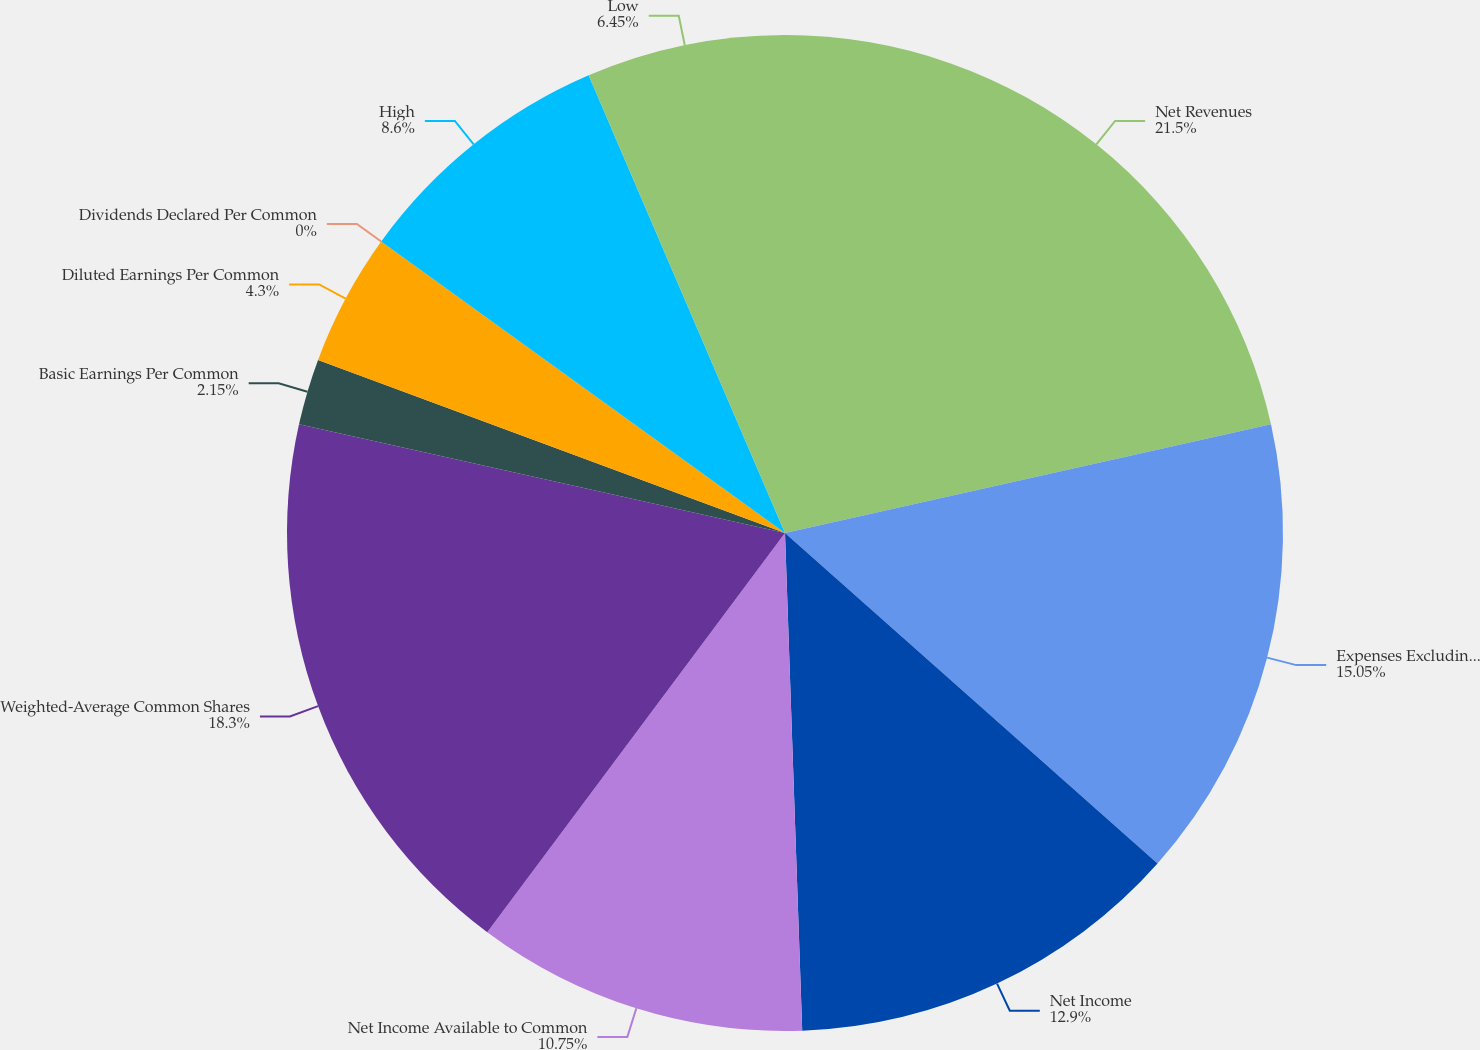<chart> <loc_0><loc_0><loc_500><loc_500><pie_chart><fcel>Net Revenues<fcel>Expenses Excluding Interest<fcel>Net Income<fcel>Net Income Available to Common<fcel>Weighted-Average Common Shares<fcel>Basic Earnings Per Common<fcel>Diluted Earnings Per Common<fcel>Dividends Declared Per Common<fcel>High<fcel>Low<nl><fcel>21.5%<fcel>15.05%<fcel>12.9%<fcel>10.75%<fcel>18.3%<fcel>2.15%<fcel>4.3%<fcel>0.0%<fcel>8.6%<fcel>6.45%<nl></chart> 